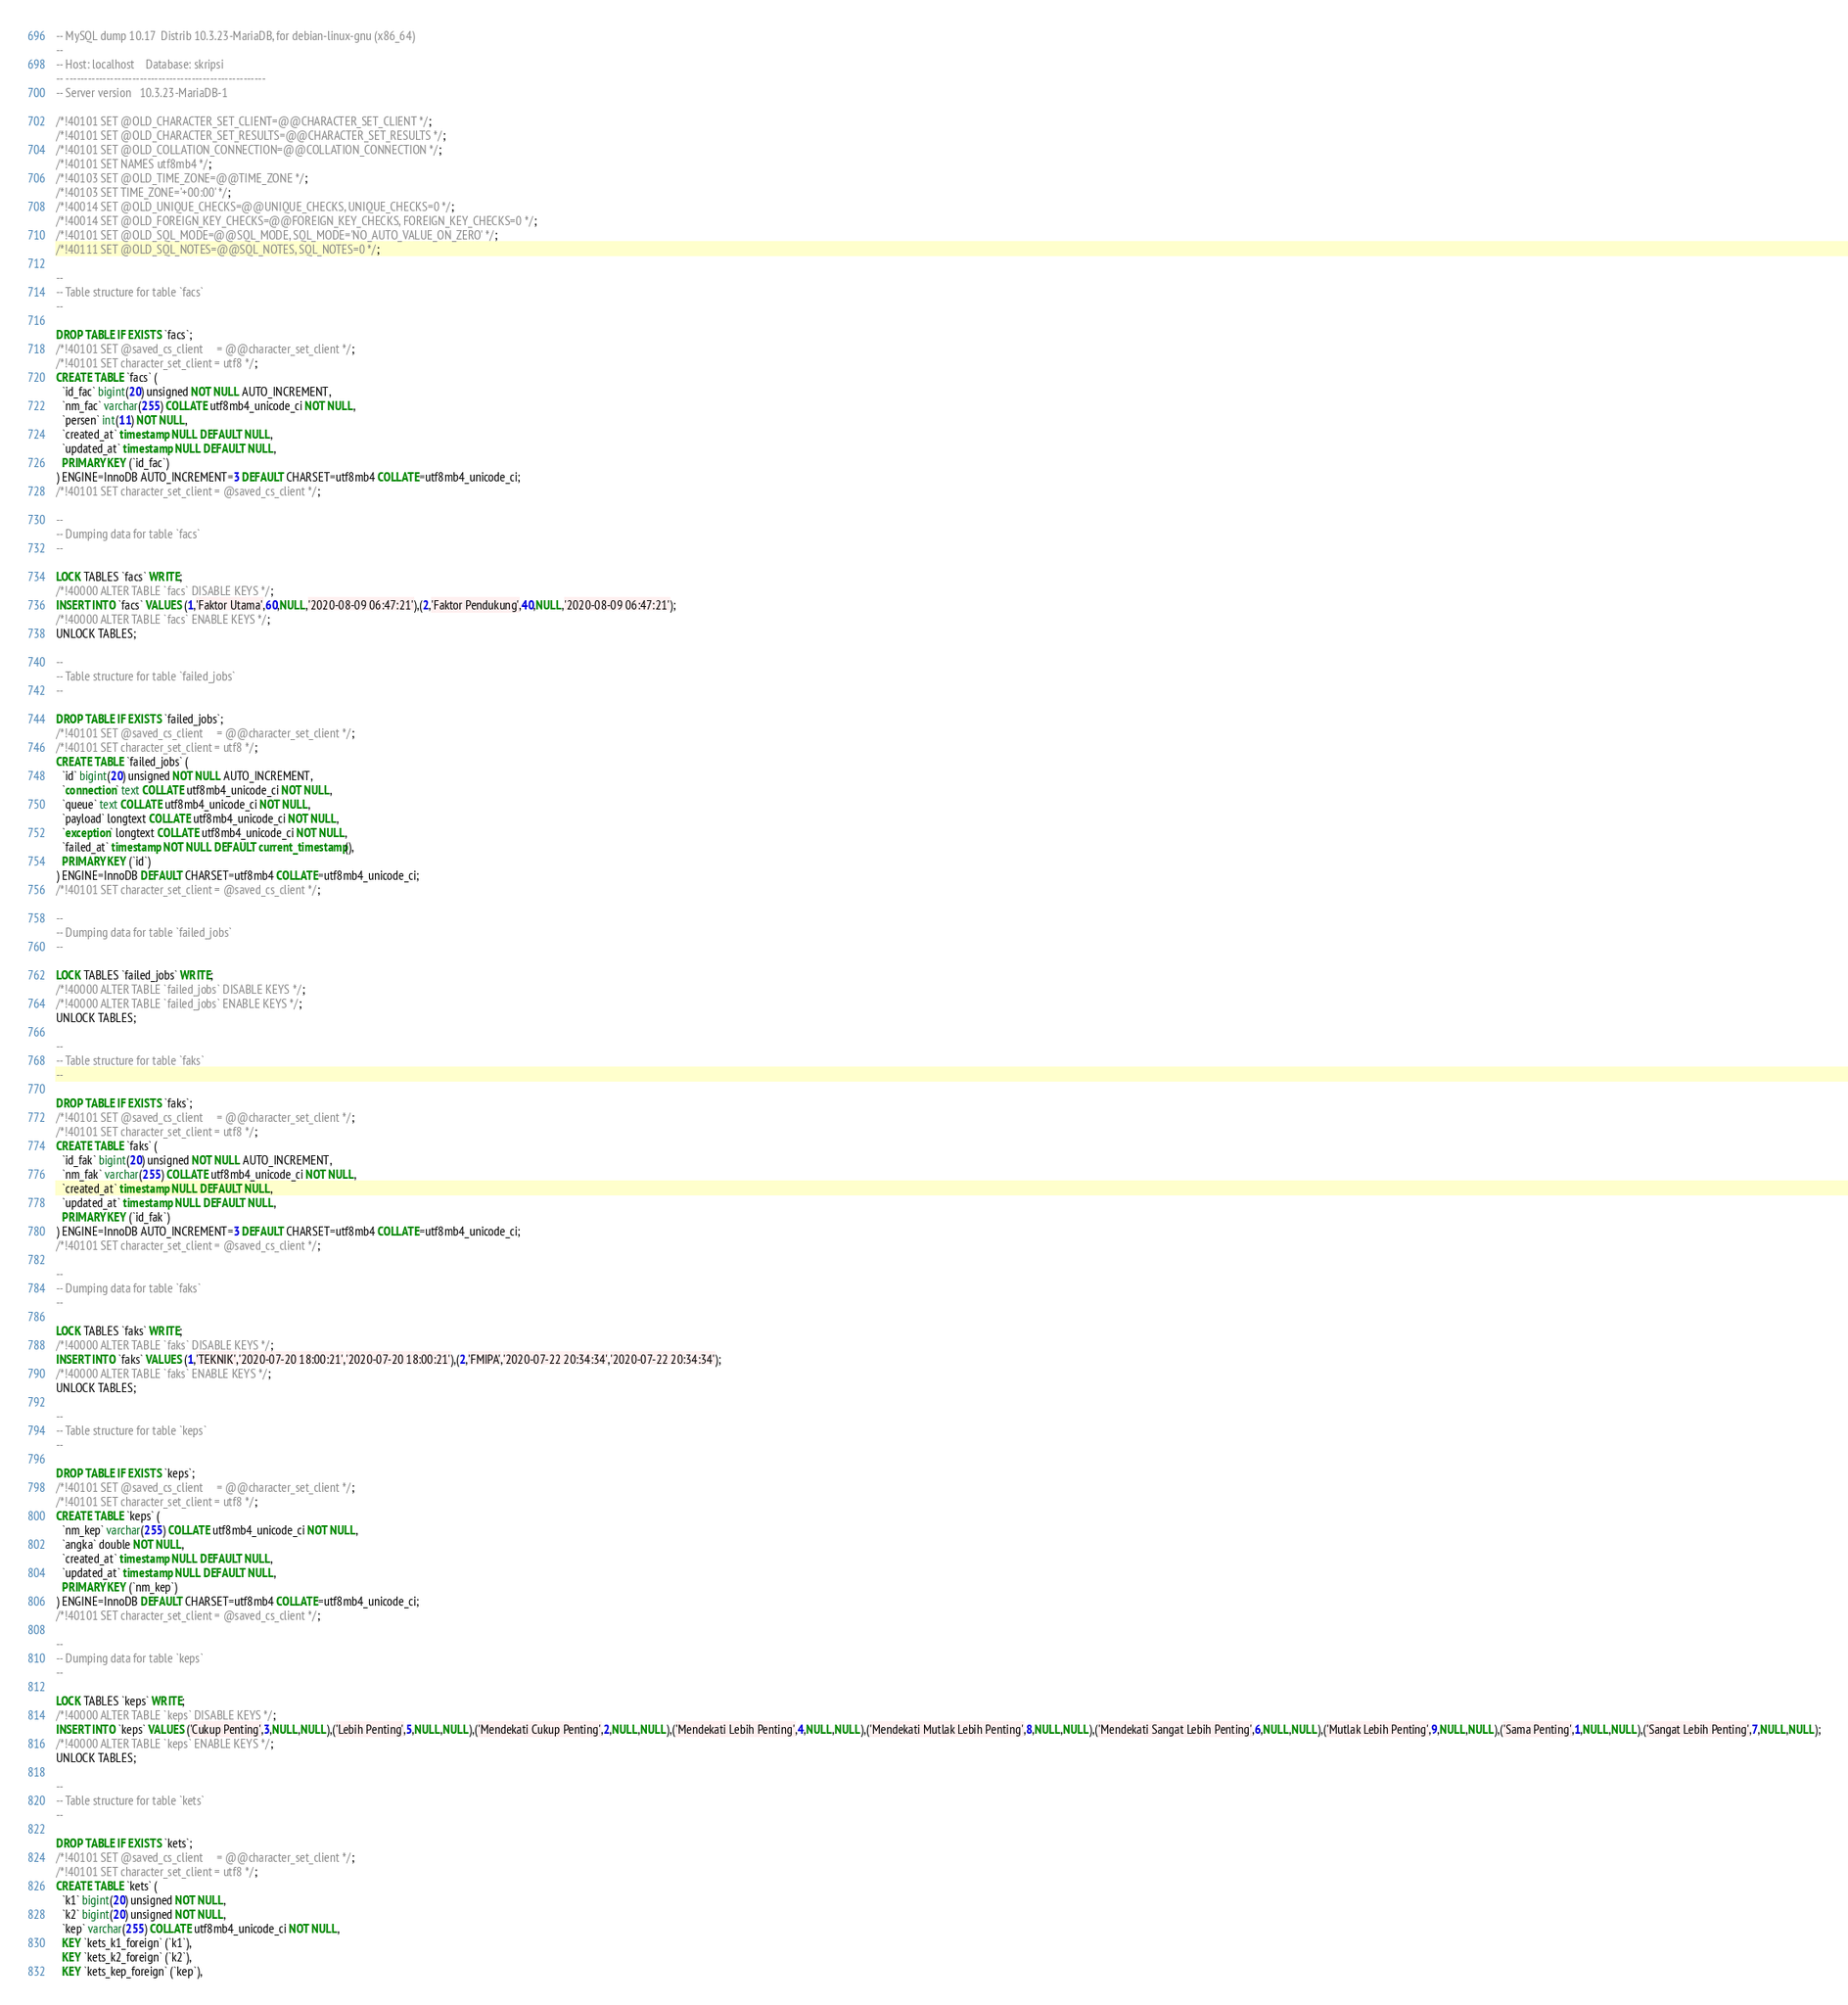Convert code to text. <code><loc_0><loc_0><loc_500><loc_500><_SQL_>-- MySQL dump 10.17  Distrib 10.3.23-MariaDB, for debian-linux-gnu (x86_64)
--
-- Host: localhost    Database: skripsi
-- ------------------------------------------------------
-- Server version	10.3.23-MariaDB-1

/*!40101 SET @OLD_CHARACTER_SET_CLIENT=@@CHARACTER_SET_CLIENT */;
/*!40101 SET @OLD_CHARACTER_SET_RESULTS=@@CHARACTER_SET_RESULTS */;
/*!40101 SET @OLD_COLLATION_CONNECTION=@@COLLATION_CONNECTION */;
/*!40101 SET NAMES utf8mb4 */;
/*!40103 SET @OLD_TIME_ZONE=@@TIME_ZONE */;
/*!40103 SET TIME_ZONE='+00:00' */;
/*!40014 SET @OLD_UNIQUE_CHECKS=@@UNIQUE_CHECKS, UNIQUE_CHECKS=0 */;
/*!40014 SET @OLD_FOREIGN_KEY_CHECKS=@@FOREIGN_KEY_CHECKS, FOREIGN_KEY_CHECKS=0 */;
/*!40101 SET @OLD_SQL_MODE=@@SQL_MODE, SQL_MODE='NO_AUTO_VALUE_ON_ZERO' */;
/*!40111 SET @OLD_SQL_NOTES=@@SQL_NOTES, SQL_NOTES=0 */;

--
-- Table structure for table `facs`
--

DROP TABLE IF EXISTS `facs`;
/*!40101 SET @saved_cs_client     = @@character_set_client */;
/*!40101 SET character_set_client = utf8 */;
CREATE TABLE `facs` (
  `id_fac` bigint(20) unsigned NOT NULL AUTO_INCREMENT,
  `nm_fac` varchar(255) COLLATE utf8mb4_unicode_ci NOT NULL,
  `persen` int(11) NOT NULL,
  `created_at` timestamp NULL DEFAULT NULL,
  `updated_at` timestamp NULL DEFAULT NULL,
  PRIMARY KEY (`id_fac`)
) ENGINE=InnoDB AUTO_INCREMENT=3 DEFAULT CHARSET=utf8mb4 COLLATE=utf8mb4_unicode_ci;
/*!40101 SET character_set_client = @saved_cs_client */;

--
-- Dumping data for table `facs`
--

LOCK TABLES `facs` WRITE;
/*!40000 ALTER TABLE `facs` DISABLE KEYS */;
INSERT INTO `facs` VALUES (1,'Faktor Utama',60,NULL,'2020-08-09 06:47:21'),(2,'Faktor Pendukung',40,NULL,'2020-08-09 06:47:21');
/*!40000 ALTER TABLE `facs` ENABLE KEYS */;
UNLOCK TABLES;

--
-- Table structure for table `failed_jobs`
--

DROP TABLE IF EXISTS `failed_jobs`;
/*!40101 SET @saved_cs_client     = @@character_set_client */;
/*!40101 SET character_set_client = utf8 */;
CREATE TABLE `failed_jobs` (
  `id` bigint(20) unsigned NOT NULL AUTO_INCREMENT,
  `connection` text COLLATE utf8mb4_unicode_ci NOT NULL,
  `queue` text COLLATE utf8mb4_unicode_ci NOT NULL,
  `payload` longtext COLLATE utf8mb4_unicode_ci NOT NULL,
  `exception` longtext COLLATE utf8mb4_unicode_ci NOT NULL,
  `failed_at` timestamp NOT NULL DEFAULT current_timestamp(),
  PRIMARY KEY (`id`)
) ENGINE=InnoDB DEFAULT CHARSET=utf8mb4 COLLATE=utf8mb4_unicode_ci;
/*!40101 SET character_set_client = @saved_cs_client */;

--
-- Dumping data for table `failed_jobs`
--

LOCK TABLES `failed_jobs` WRITE;
/*!40000 ALTER TABLE `failed_jobs` DISABLE KEYS */;
/*!40000 ALTER TABLE `failed_jobs` ENABLE KEYS */;
UNLOCK TABLES;

--
-- Table structure for table `faks`
--

DROP TABLE IF EXISTS `faks`;
/*!40101 SET @saved_cs_client     = @@character_set_client */;
/*!40101 SET character_set_client = utf8 */;
CREATE TABLE `faks` (
  `id_fak` bigint(20) unsigned NOT NULL AUTO_INCREMENT,
  `nm_fak` varchar(255) COLLATE utf8mb4_unicode_ci NOT NULL,
  `created_at` timestamp NULL DEFAULT NULL,
  `updated_at` timestamp NULL DEFAULT NULL,
  PRIMARY KEY (`id_fak`)
) ENGINE=InnoDB AUTO_INCREMENT=3 DEFAULT CHARSET=utf8mb4 COLLATE=utf8mb4_unicode_ci;
/*!40101 SET character_set_client = @saved_cs_client */;

--
-- Dumping data for table `faks`
--

LOCK TABLES `faks` WRITE;
/*!40000 ALTER TABLE `faks` DISABLE KEYS */;
INSERT INTO `faks` VALUES (1,'TEKNIK','2020-07-20 18:00:21','2020-07-20 18:00:21'),(2,'FMIPA','2020-07-22 20:34:34','2020-07-22 20:34:34');
/*!40000 ALTER TABLE `faks` ENABLE KEYS */;
UNLOCK TABLES;

--
-- Table structure for table `keps`
--

DROP TABLE IF EXISTS `keps`;
/*!40101 SET @saved_cs_client     = @@character_set_client */;
/*!40101 SET character_set_client = utf8 */;
CREATE TABLE `keps` (
  `nm_kep` varchar(255) COLLATE utf8mb4_unicode_ci NOT NULL,
  `angka` double NOT NULL,
  `created_at` timestamp NULL DEFAULT NULL,
  `updated_at` timestamp NULL DEFAULT NULL,
  PRIMARY KEY (`nm_kep`)
) ENGINE=InnoDB DEFAULT CHARSET=utf8mb4 COLLATE=utf8mb4_unicode_ci;
/*!40101 SET character_set_client = @saved_cs_client */;

--
-- Dumping data for table `keps`
--

LOCK TABLES `keps` WRITE;
/*!40000 ALTER TABLE `keps` DISABLE KEYS */;
INSERT INTO `keps` VALUES ('Cukup Penting',3,NULL,NULL),('Lebih Penting',5,NULL,NULL),('Mendekati Cukup Penting',2,NULL,NULL),('Mendekati Lebih Penting',4,NULL,NULL),('Mendekati Mutlak Lebih Penting',8,NULL,NULL),('Mendekati Sangat Lebih Penting',6,NULL,NULL),('Mutlak Lebih Penting',9,NULL,NULL),('Sama Penting',1,NULL,NULL),('Sangat Lebih Penting',7,NULL,NULL);
/*!40000 ALTER TABLE `keps` ENABLE KEYS */;
UNLOCK TABLES;

--
-- Table structure for table `kets`
--

DROP TABLE IF EXISTS `kets`;
/*!40101 SET @saved_cs_client     = @@character_set_client */;
/*!40101 SET character_set_client = utf8 */;
CREATE TABLE `kets` (
  `k1` bigint(20) unsigned NOT NULL,
  `k2` bigint(20) unsigned NOT NULL,
  `kep` varchar(255) COLLATE utf8mb4_unicode_ci NOT NULL,
  KEY `kets_k1_foreign` (`k1`),
  KEY `kets_k2_foreign` (`k2`),
  KEY `kets_kep_foreign` (`kep`),</code> 